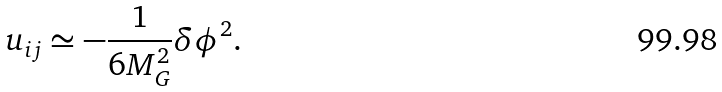Convert formula to latex. <formula><loc_0><loc_0><loc_500><loc_500>u _ { i j } \simeq - \frac { 1 } { 6 M _ { G } ^ { 2 } } \delta \phi ^ { 2 } .</formula> 